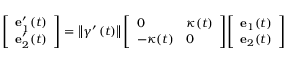Convert formula to latex. <formula><loc_0><loc_0><loc_500><loc_500>{ \left [ \begin{array} { l } { e _ { 1 } ^ { \prime } ( t ) } \\ { e _ { 2 } ^ { \prime } ( t ) } \end{array} \right ] } = \left \| \gamma ^ { \prime } \left ( t \right ) \right \| { \left [ \begin{array} { l l } { 0 } & { \kappa ( t ) } \\ { - \kappa ( t ) } & { 0 } \end{array} \right ] } { \left [ \begin{array} { l } { e _ { 1 } ( t ) } \\ { e _ { 2 } ( t ) } \end{array} \right ] }</formula> 